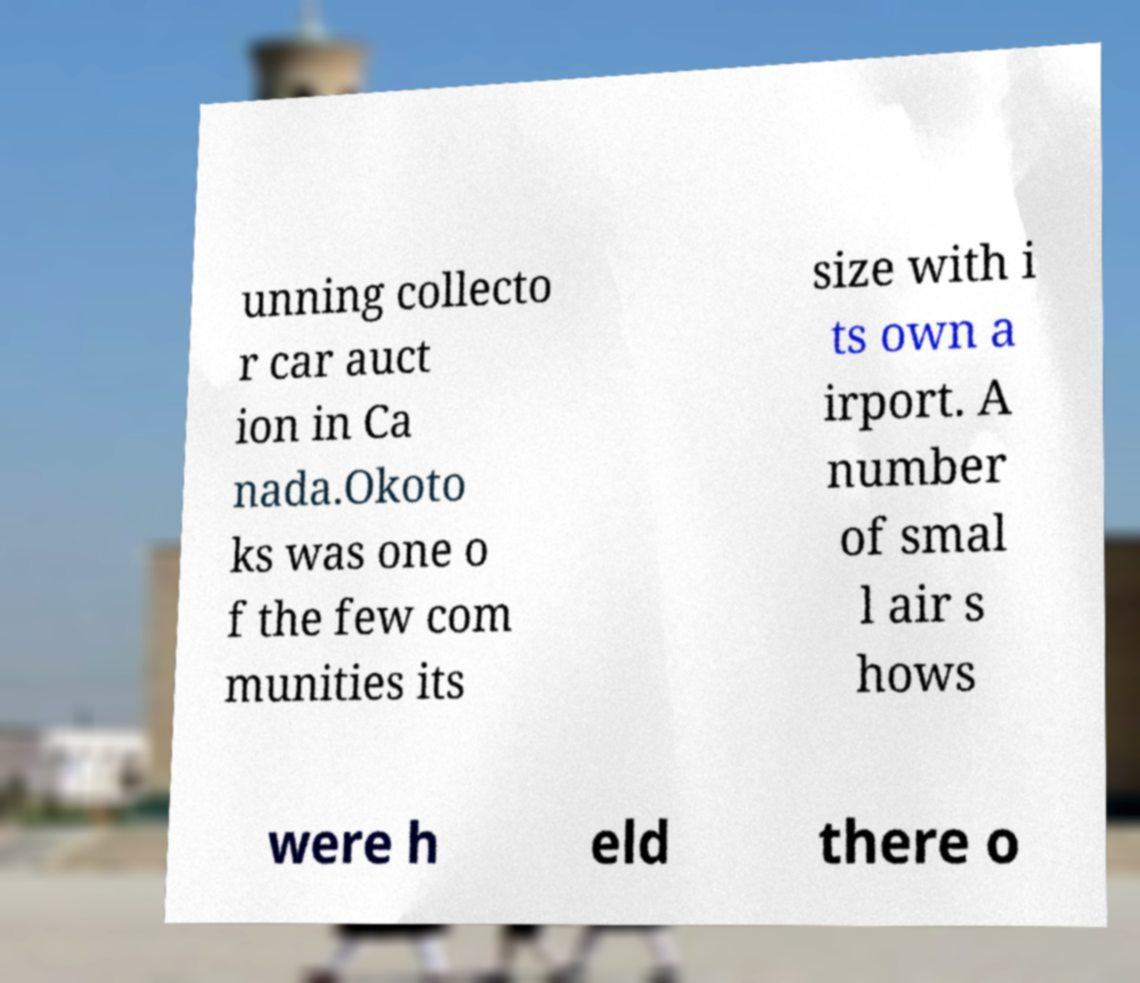Please read and relay the text visible in this image. What does it say? unning collecto r car auct ion in Ca nada.Okoto ks was one o f the few com munities its size with i ts own a irport. A number of smal l air s hows were h eld there o 